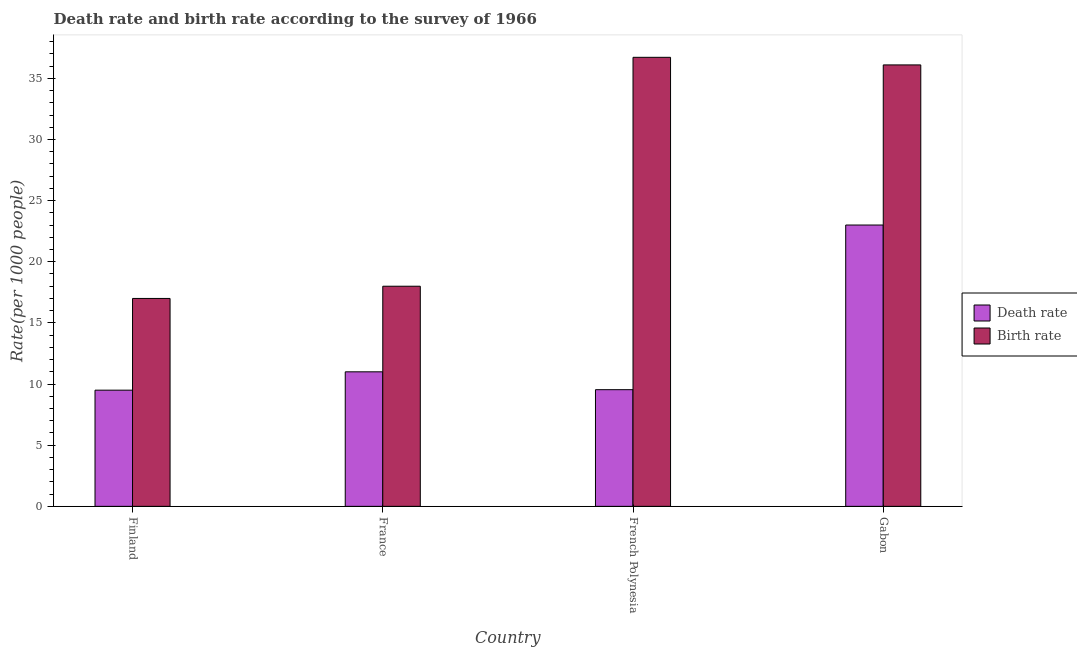How many different coloured bars are there?
Make the answer very short. 2. How many groups of bars are there?
Your answer should be compact. 4. In how many cases, is the number of bars for a given country not equal to the number of legend labels?
Give a very brief answer. 0. Across all countries, what is the maximum death rate?
Your answer should be compact. 23. In which country was the death rate maximum?
Make the answer very short. Gabon. What is the total death rate in the graph?
Keep it short and to the point. 53.04. What is the difference between the birth rate in French Polynesia and that in Gabon?
Offer a terse response. 0.62. What is the difference between the death rate in Gabon and the birth rate in Finland?
Your answer should be very brief. 6. What is the average death rate per country?
Make the answer very short. 13.26. What is the difference between the death rate and birth rate in Gabon?
Offer a very short reply. -13.09. In how many countries, is the death rate greater than 23 ?
Give a very brief answer. 1. What is the ratio of the death rate in France to that in Gabon?
Provide a succinct answer. 0.48. Is the death rate in Finland less than that in Gabon?
Your answer should be very brief. Yes. What is the difference between the highest and the second highest death rate?
Make the answer very short. 12. What is the difference between the highest and the lowest death rate?
Your answer should be compact. 13.5. In how many countries, is the death rate greater than the average death rate taken over all countries?
Ensure brevity in your answer.  1. What does the 1st bar from the left in Finland represents?
Offer a very short reply. Death rate. What does the 1st bar from the right in France represents?
Provide a succinct answer. Birth rate. Are all the bars in the graph horizontal?
Provide a succinct answer. No. How many countries are there in the graph?
Offer a very short reply. 4. What is the difference between two consecutive major ticks on the Y-axis?
Ensure brevity in your answer.  5. Does the graph contain any zero values?
Your answer should be very brief. No. Does the graph contain grids?
Offer a very short reply. No. Where does the legend appear in the graph?
Keep it short and to the point. Center right. How are the legend labels stacked?
Give a very brief answer. Vertical. What is the title of the graph?
Your answer should be very brief. Death rate and birth rate according to the survey of 1966. What is the label or title of the X-axis?
Provide a short and direct response. Country. What is the label or title of the Y-axis?
Ensure brevity in your answer.  Rate(per 1000 people). What is the Rate(per 1000 people) in Death rate in Finland?
Provide a succinct answer. 9.5. What is the Rate(per 1000 people) of Birth rate in Finland?
Provide a succinct answer. 17. What is the Rate(per 1000 people) of Death rate in France?
Ensure brevity in your answer.  11. What is the Rate(per 1000 people) of Birth rate in France?
Your response must be concise. 18. What is the Rate(per 1000 people) in Death rate in French Polynesia?
Provide a short and direct response. 9.54. What is the Rate(per 1000 people) of Birth rate in French Polynesia?
Ensure brevity in your answer.  36.72. What is the Rate(per 1000 people) of Death rate in Gabon?
Provide a succinct answer. 23. What is the Rate(per 1000 people) of Birth rate in Gabon?
Ensure brevity in your answer.  36.1. Across all countries, what is the maximum Rate(per 1000 people) of Death rate?
Offer a very short reply. 23. Across all countries, what is the maximum Rate(per 1000 people) of Birth rate?
Make the answer very short. 36.72. What is the total Rate(per 1000 people) in Death rate in the graph?
Make the answer very short. 53.04. What is the total Rate(per 1000 people) in Birth rate in the graph?
Make the answer very short. 107.81. What is the difference between the Rate(per 1000 people) in Death rate in Finland and that in France?
Make the answer very short. -1.5. What is the difference between the Rate(per 1000 people) of Birth rate in Finland and that in France?
Your response must be concise. -1. What is the difference between the Rate(per 1000 people) of Death rate in Finland and that in French Polynesia?
Offer a very short reply. -0.04. What is the difference between the Rate(per 1000 people) in Birth rate in Finland and that in French Polynesia?
Your answer should be compact. -19.72. What is the difference between the Rate(per 1000 people) of Death rate in Finland and that in Gabon?
Offer a terse response. -13.5. What is the difference between the Rate(per 1000 people) in Birth rate in Finland and that in Gabon?
Your response must be concise. -19.1. What is the difference between the Rate(per 1000 people) of Death rate in France and that in French Polynesia?
Provide a short and direct response. 1.46. What is the difference between the Rate(per 1000 people) in Birth rate in France and that in French Polynesia?
Your answer should be compact. -18.72. What is the difference between the Rate(per 1000 people) in Death rate in France and that in Gabon?
Ensure brevity in your answer.  -12. What is the difference between the Rate(per 1000 people) in Birth rate in France and that in Gabon?
Ensure brevity in your answer.  -18.1. What is the difference between the Rate(per 1000 people) in Death rate in French Polynesia and that in Gabon?
Provide a succinct answer. -13.46. What is the difference between the Rate(per 1000 people) of Birth rate in French Polynesia and that in Gabon?
Your answer should be very brief. 0.62. What is the difference between the Rate(per 1000 people) in Death rate in Finland and the Rate(per 1000 people) in Birth rate in French Polynesia?
Ensure brevity in your answer.  -27.22. What is the difference between the Rate(per 1000 people) in Death rate in Finland and the Rate(per 1000 people) in Birth rate in Gabon?
Offer a very short reply. -26.6. What is the difference between the Rate(per 1000 people) in Death rate in France and the Rate(per 1000 people) in Birth rate in French Polynesia?
Your answer should be compact. -25.72. What is the difference between the Rate(per 1000 people) in Death rate in France and the Rate(per 1000 people) in Birth rate in Gabon?
Give a very brief answer. -25.1. What is the difference between the Rate(per 1000 people) of Death rate in French Polynesia and the Rate(per 1000 people) of Birth rate in Gabon?
Your response must be concise. -26.56. What is the average Rate(per 1000 people) in Death rate per country?
Make the answer very short. 13.26. What is the average Rate(per 1000 people) of Birth rate per country?
Ensure brevity in your answer.  26.95. What is the difference between the Rate(per 1000 people) of Death rate and Rate(per 1000 people) of Birth rate in Finland?
Provide a short and direct response. -7.5. What is the difference between the Rate(per 1000 people) in Death rate and Rate(per 1000 people) in Birth rate in France?
Ensure brevity in your answer.  -7. What is the difference between the Rate(per 1000 people) in Death rate and Rate(per 1000 people) in Birth rate in French Polynesia?
Offer a terse response. -27.18. What is the difference between the Rate(per 1000 people) in Death rate and Rate(per 1000 people) in Birth rate in Gabon?
Your answer should be compact. -13.09. What is the ratio of the Rate(per 1000 people) of Death rate in Finland to that in France?
Offer a very short reply. 0.86. What is the ratio of the Rate(per 1000 people) of Death rate in Finland to that in French Polynesia?
Offer a terse response. 1. What is the ratio of the Rate(per 1000 people) of Birth rate in Finland to that in French Polynesia?
Provide a succinct answer. 0.46. What is the ratio of the Rate(per 1000 people) of Death rate in Finland to that in Gabon?
Your answer should be very brief. 0.41. What is the ratio of the Rate(per 1000 people) in Birth rate in Finland to that in Gabon?
Give a very brief answer. 0.47. What is the ratio of the Rate(per 1000 people) of Death rate in France to that in French Polynesia?
Provide a succinct answer. 1.15. What is the ratio of the Rate(per 1000 people) of Birth rate in France to that in French Polynesia?
Provide a short and direct response. 0.49. What is the ratio of the Rate(per 1000 people) of Death rate in France to that in Gabon?
Offer a terse response. 0.48. What is the ratio of the Rate(per 1000 people) in Birth rate in France to that in Gabon?
Give a very brief answer. 0.5. What is the ratio of the Rate(per 1000 people) of Death rate in French Polynesia to that in Gabon?
Provide a succinct answer. 0.41. What is the ratio of the Rate(per 1000 people) of Birth rate in French Polynesia to that in Gabon?
Keep it short and to the point. 1.02. What is the difference between the highest and the second highest Rate(per 1000 people) in Death rate?
Provide a short and direct response. 12. What is the difference between the highest and the second highest Rate(per 1000 people) of Birth rate?
Give a very brief answer. 0.62. What is the difference between the highest and the lowest Rate(per 1000 people) in Death rate?
Your answer should be very brief. 13.5. What is the difference between the highest and the lowest Rate(per 1000 people) in Birth rate?
Offer a very short reply. 19.72. 